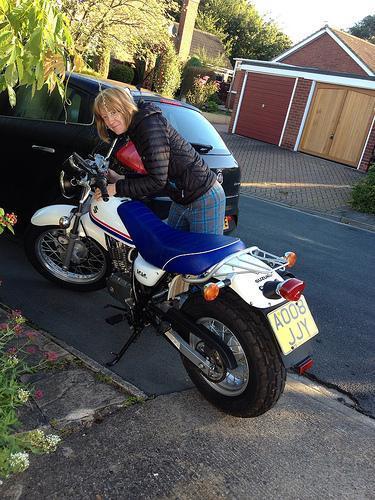How many vehicles are there?
Give a very brief answer. 2. How many people are in the photo?
Give a very brief answer. 1. 